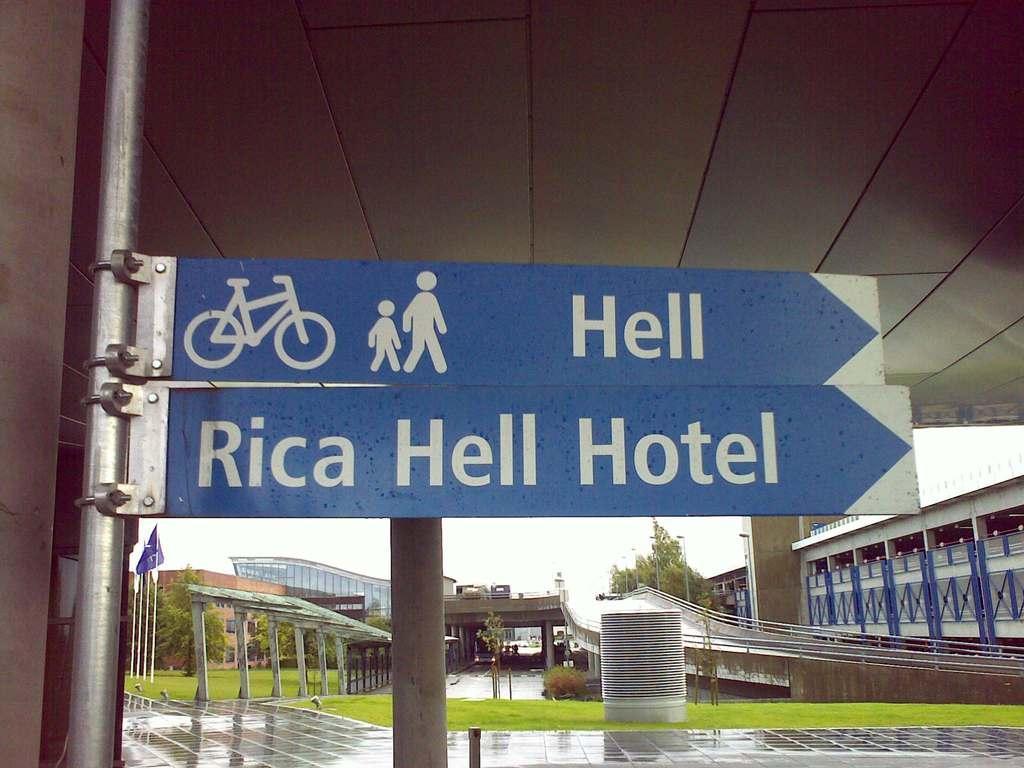Please provide a concise description of this image. In this picture we can see few sign boards, poles and grass, in the background we can find few flags, buildings and trees. 